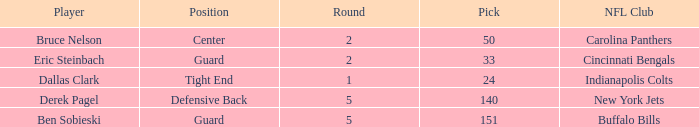During which round was a Hawkeyes player selected for the defensive back position? 5.0. 